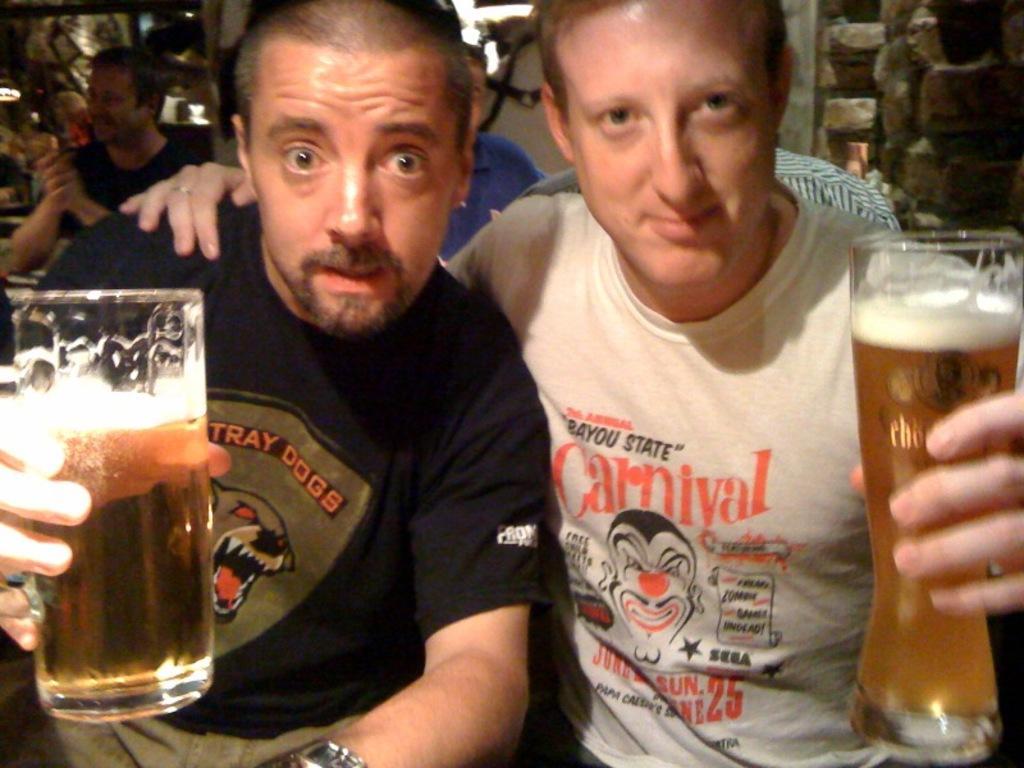Please provide a concise description of this image. In the picture we can see two men are sitting and holding a wine glasses with wine. In the background we can see some other people are also sitting. 